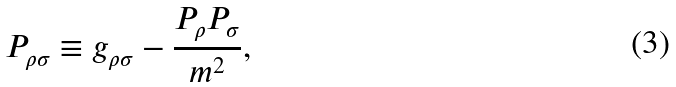Convert formula to latex. <formula><loc_0><loc_0><loc_500><loc_500>P _ { \rho \sigma } \equiv g _ { \rho \sigma } - \frac { P _ { \rho } P _ { \sigma } } { m ^ { 2 } } ,</formula> 